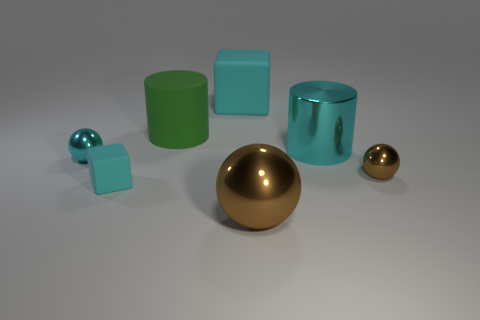How would you describe the texture of the objects? The objects appear to have a smooth and shiny texture, suggesting they are possibly made of plastic or metal with a reflective surface finish. 